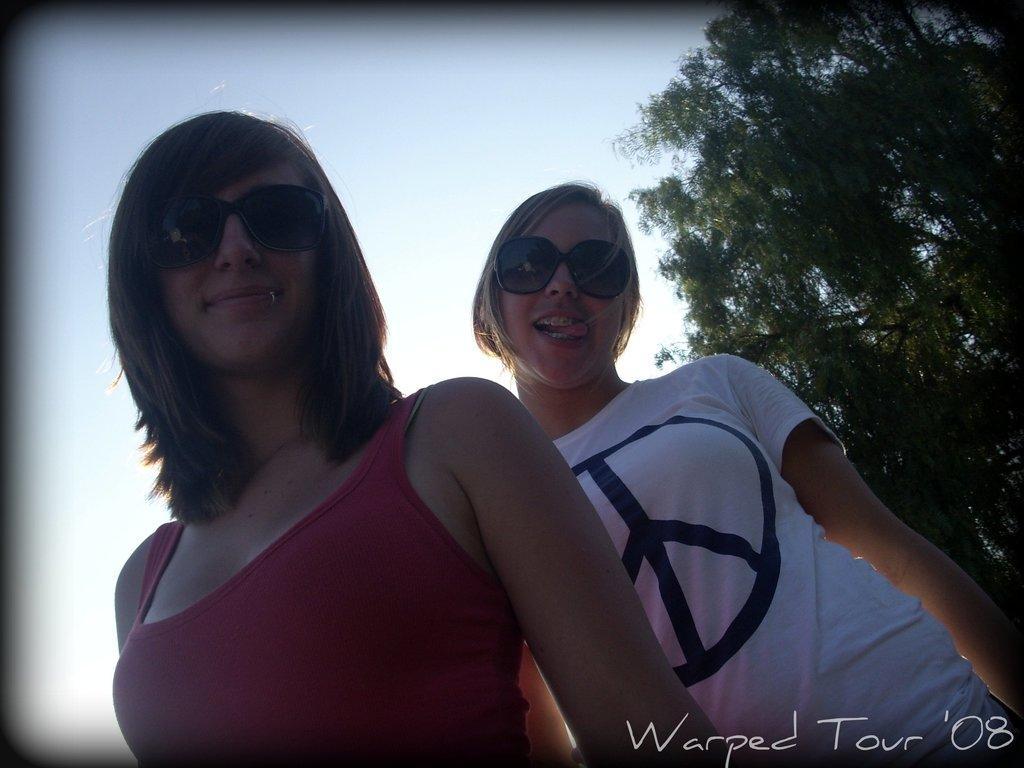Can you describe this image briefly? In this image I can see two people with red and white color dresses. And these people are wearing the goggles. To the right I can see the tree and there is a sky in the back. 